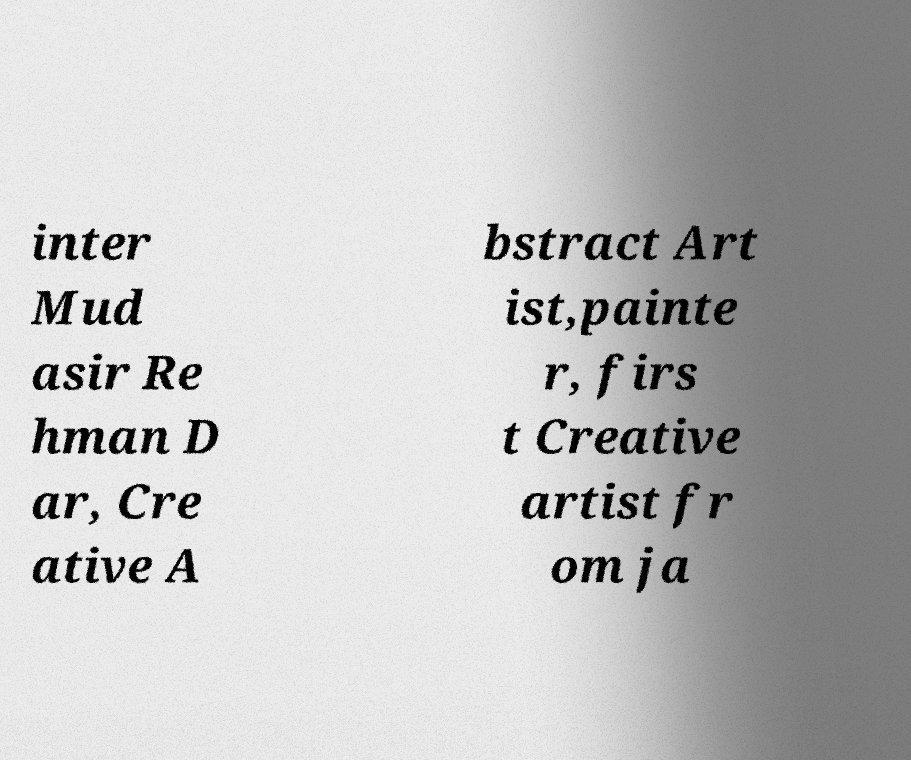Can you read and provide the text displayed in the image?This photo seems to have some interesting text. Can you extract and type it out for me? inter Mud asir Re hman D ar, Cre ative A bstract Art ist,painte r, firs t Creative artist fr om ja 